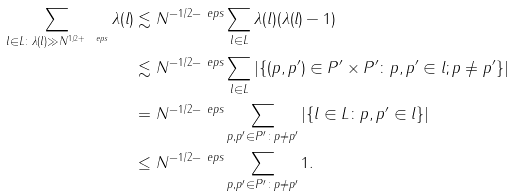Convert formula to latex. <formula><loc_0><loc_0><loc_500><loc_500>\sum _ { l \in L \colon \lambda ( l ) \gg N ^ { 1 / 2 + \ e p s } } \lambda ( l ) & \lesssim N ^ { - 1 / 2 - \ e p s } \sum _ { l \in L } \lambda ( l ) ( \lambda ( l ) - 1 ) \\ & \lesssim N ^ { - 1 / 2 - \ e p s } \sum _ { l \in L } | \{ ( p , p ^ { \prime } ) \in P ^ { \prime } \times P ^ { \prime } \colon p , p ^ { \prime } \in l ; p \neq p ^ { \prime } \} | \\ & = N ^ { - 1 / 2 - \ e p s } \sum _ { p , p ^ { \prime } \in P ^ { \prime } \colon p \neq p ^ { \prime } } | \{ l \in L \colon p , p ^ { \prime } \in l \} | \\ & \leq N ^ { - 1 / 2 - \ e p s } \sum _ { p , p ^ { \prime } \in P ^ { \prime } \colon p \neq p ^ { \prime } } 1 .</formula> 